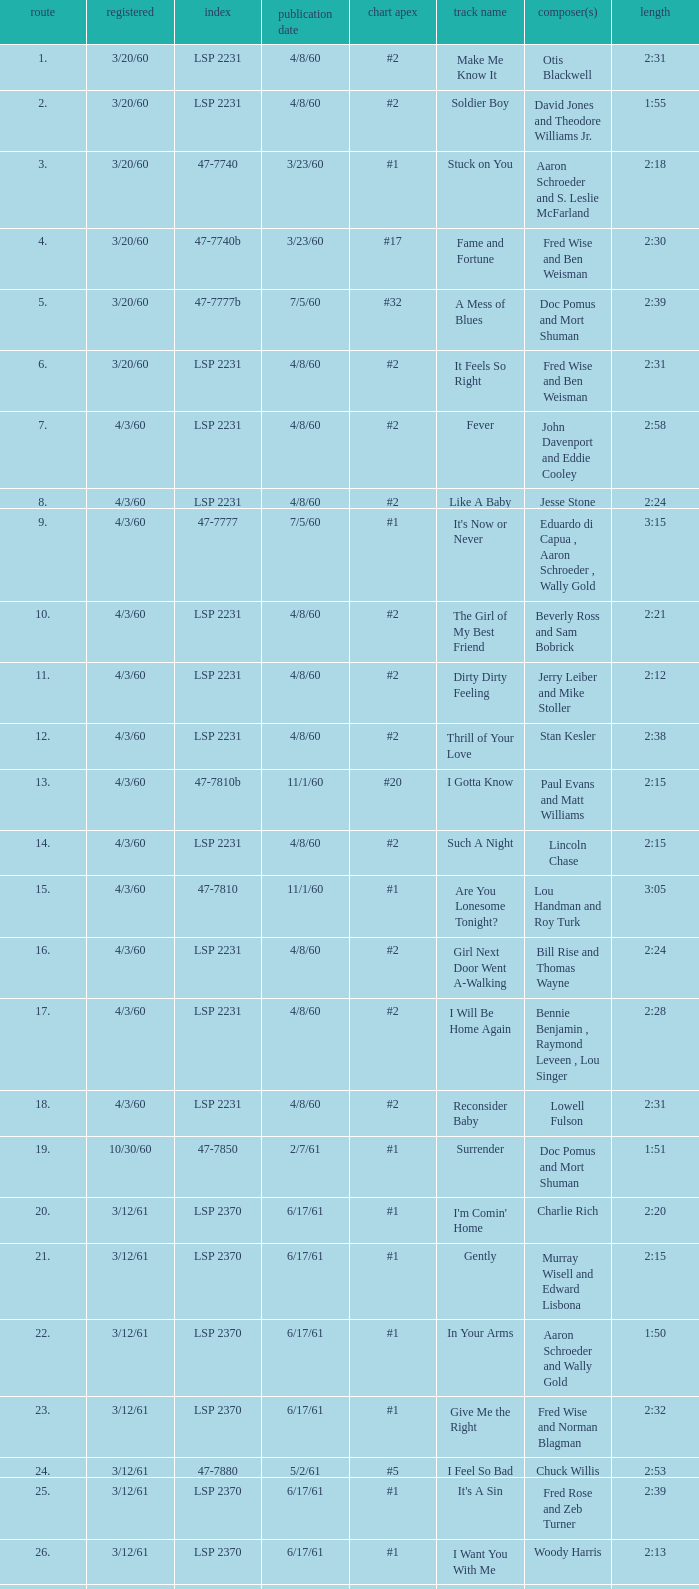Can you give me this table as a dict? {'header': ['route', 'registered', 'index', 'publication date', 'chart apex', 'track name', 'composer(s)', 'length'], 'rows': [['1.', '3/20/60', 'LSP 2231', '4/8/60', '#2', 'Make Me Know It', 'Otis Blackwell', '2:31'], ['2.', '3/20/60', 'LSP 2231', '4/8/60', '#2', 'Soldier Boy', 'David Jones and Theodore Williams Jr.', '1:55'], ['3.', '3/20/60', '47-7740', '3/23/60', '#1', 'Stuck on You', 'Aaron Schroeder and S. Leslie McFarland', '2:18'], ['4.', '3/20/60', '47-7740b', '3/23/60', '#17', 'Fame and Fortune', 'Fred Wise and Ben Weisman', '2:30'], ['5.', '3/20/60', '47-7777b', '7/5/60', '#32', 'A Mess of Blues', 'Doc Pomus and Mort Shuman', '2:39'], ['6.', '3/20/60', 'LSP 2231', '4/8/60', '#2', 'It Feels So Right', 'Fred Wise and Ben Weisman', '2:31'], ['7.', '4/3/60', 'LSP 2231', '4/8/60', '#2', 'Fever', 'John Davenport and Eddie Cooley', '2:58'], ['8.', '4/3/60', 'LSP 2231', '4/8/60', '#2', 'Like A Baby', 'Jesse Stone', '2:24'], ['9.', '4/3/60', '47-7777', '7/5/60', '#1', "It's Now or Never", 'Eduardo di Capua , Aaron Schroeder , Wally Gold', '3:15'], ['10.', '4/3/60', 'LSP 2231', '4/8/60', '#2', 'The Girl of My Best Friend', 'Beverly Ross and Sam Bobrick', '2:21'], ['11.', '4/3/60', 'LSP 2231', '4/8/60', '#2', 'Dirty Dirty Feeling', 'Jerry Leiber and Mike Stoller', '2:12'], ['12.', '4/3/60', 'LSP 2231', '4/8/60', '#2', 'Thrill of Your Love', 'Stan Kesler', '2:38'], ['13.', '4/3/60', '47-7810b', '11/1/60', '#20', 'I Gotta Know', 'Paul Evans and Matt Williams', '2:15'], ['14.', '4/3/60', 'LSP 2231', '4/8/60', '#2', 'Such A Night', 'Lincoln Chase', '2:15'], ['15.', '4/3/60', '47-7810', '11/1/60', '#1', 'Are You Lonesome Tonight?', 'Lou Handman and Roy Turk', '3:05'], ['16.', '4/3/60', 'LSP 2231', '4/8/60', '#2', 'Girl Next Door Went A-Walking', 'Bill Rise and Thomas Wayne', '2:24'], ['17.', '4/3/60', 'LSP 2231', '4/8/60', '#2', 'I Will Be Home Again', 'Bennie Benjamin , Raymond Leveen , Lou Singer', '2:28'], ['18.', '4/3/60', 'LSP 2231', '4/8/60', '#2', 'Reconsider Baby', 'Lowell Fulson', '2:31'], ['19.', '10/30/60', '47-7850', '2/7/61', '#1', 'Surrender', 'Doc Pomus and Mort Shuman', '1:51'], ['20.', '3/12/61', 'LSP 2370', '6/17/61', '#1', "I'm Comin' Home", 'Charlie Rich', '2:20'], ['21.', '3/12/61', 'LSP 2370', '6/17/61', '#1', 'Gently', 'Murray Wisell and Edward Lisbona', '2:15'], ['22.', '3/12/61', 'LSP 2370', '6/17/61', '#1', 'In Your Arms', 'Aaron Schroeder and Wally Gold', '1:50'], ['23.', '3/12/61', 'LSP 2370', '6/17/61', '#1', 'Give Me the Right', 'Fred Wise and Norman Blagman', '2:32'], ['24.', '3/12/61', '47-7880', '5/2/61', '#5', 'I Feel So Bad', 'Chuck Willis', '2:53'], ['25.', '3/12/61', 'LSP 2370', '6/17/61', '#1', "It's A Sin", 'Fred Rose and Zeb Turner', '2:39'], ['26.', '3/12/61', 'LSP 2370', '6/17/61', '#1', 'I Want You With Me', 'Woody Harris', '2:13'], ['27.', '3/12/61', 'LSP 2370', '6/17/61', '#1', "There's Always Me", 'Don Robertson', '2:16']]} On songs that have a release date of 6/17/61, a track larger than 20, and a writer of Woody Harris, what is the chart peak? #1. 